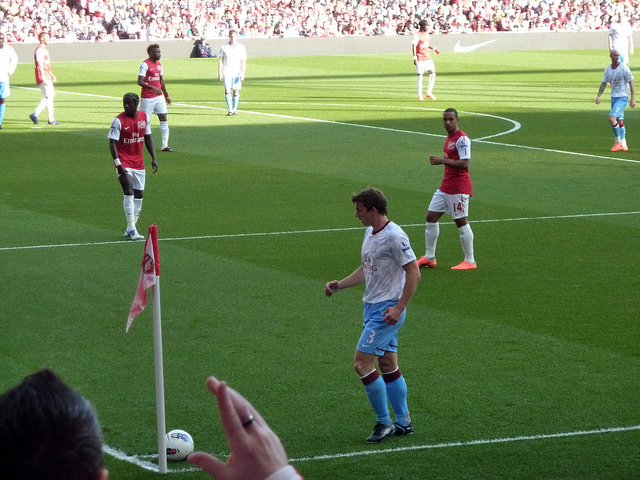Extract all visible text content from this image. 14 